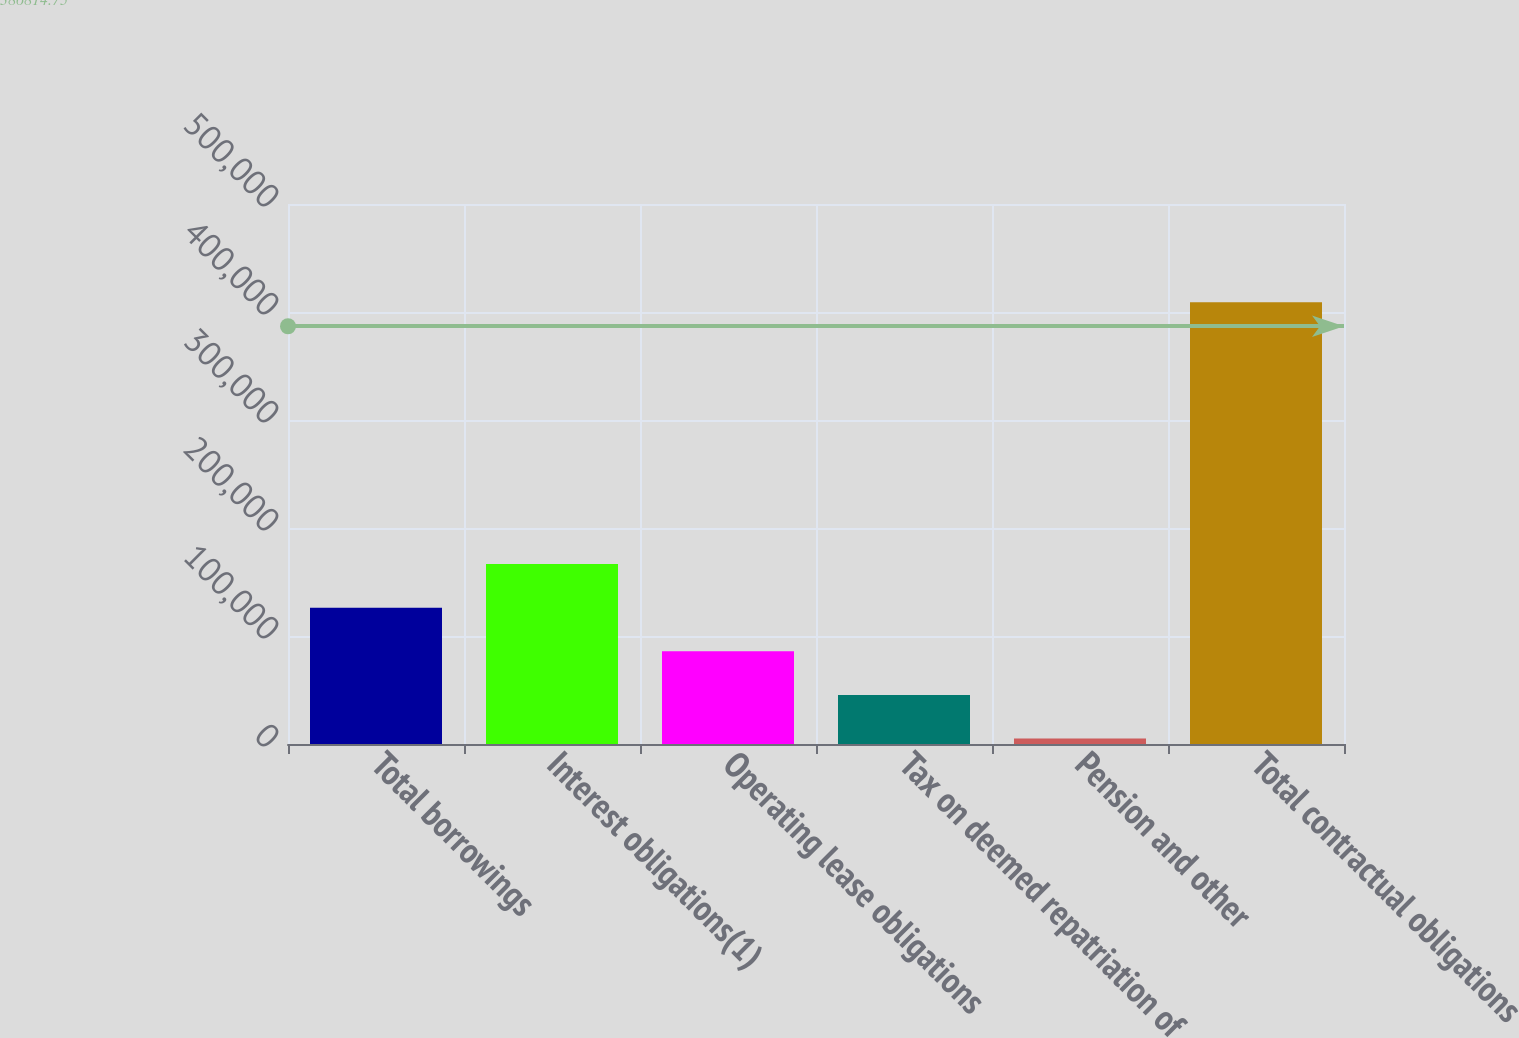<chart> <loc_0><loc_0><loc_500><loc_500><bar_chart><fcel>Total borrowings<fcel>Interest obligations(1)<fcel>Operating lease obligations<fcel>Tax on deemed repatriation of<fcel>Pension and other<fcel>Total contractual obligations<nl><fcel>126271<fcel>166671<fcel>85871.8<fcel>45472.4<fcel>5073<fcel>409067<nl></chart> 